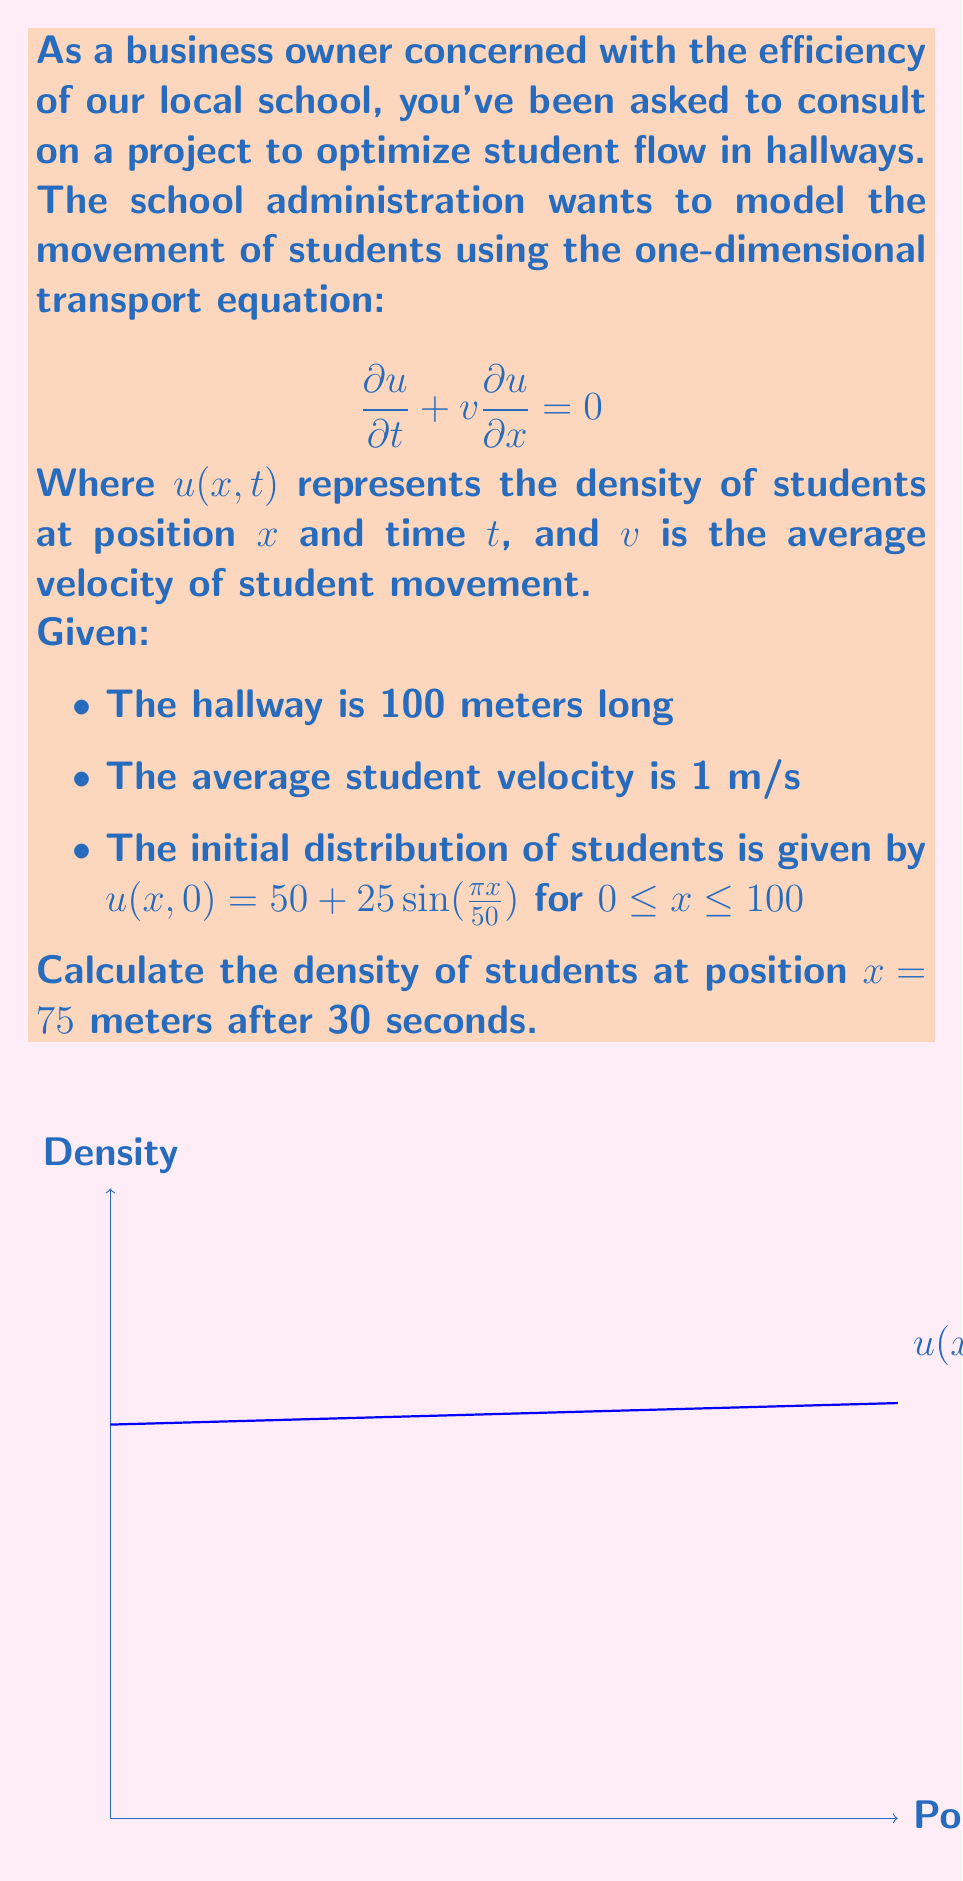Show me your answer to this math problem. To solve this problem, we'll follow these steps:

1) The general solution to the transport equation is:
   $$u(x,t) = u(x-vt, 0)$$
   This means the initial distribution simply moves to the right at velocity $v$.

2) After 30 seconds, the distribution will have moved 30 meters to the right (since $v = 1$ m/s).

3) To find the density at $x = 75$ m after 30 seconds, we need to calculate $u(75-30, 0)$, which is $u(45, 0)$.

4) Plugging this into our initial distribution function:
   $$u(45, 0) = 50 + 25\sin(\frac{\pi \cdot 45}{50})$$

5) Simplifying:
   $$u(45, 0) = 50 + 25\sin(\frac{9\pi}{10})$$

6) Calculate:
   $$u(45, 0) = 50 + 25 \cdot 0.9511 = 73.7775$$

Therefore, the density of students at position $x = 75$ meters after 30 seconds is approximately 73.78 students per unit length.
Answer: 73.78 students/unit length 